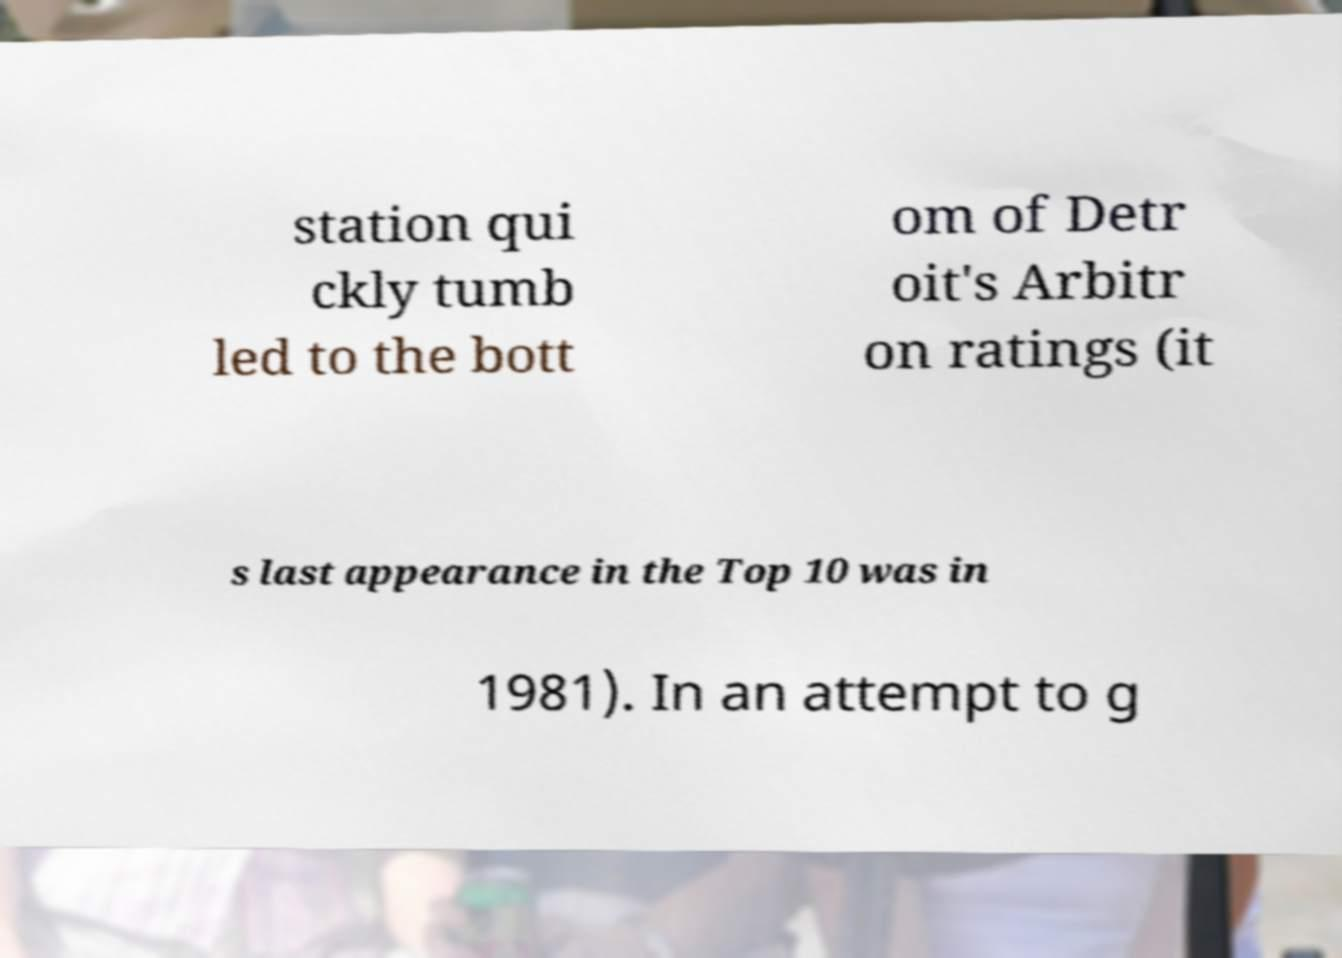I need the written content from this picture converted into text. Can you do that? station qui ckly tumb led to the bott om of Detr oit's Arbitr on ratings (it s last appearance in the Top 10 was in 1981). In an attempt to g 